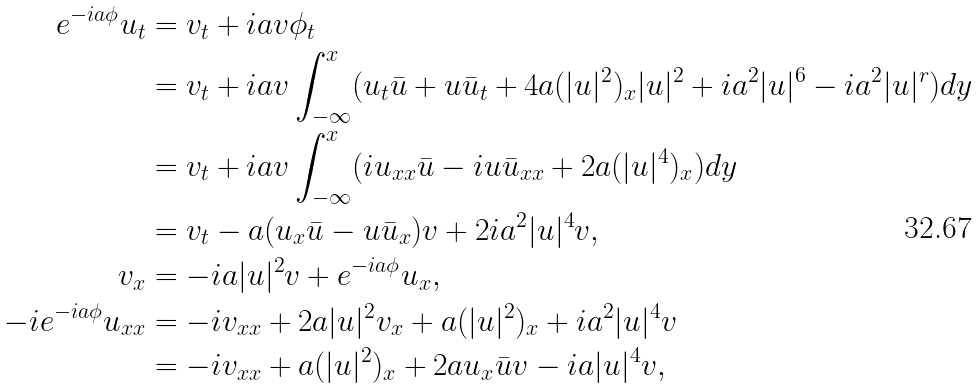Convert formula to latex. <formula><loc_0><loc_0><loc_500><loc_500>e ^ { - i a \phi } u _ { t } & = v _ { t } + i a v \phi _ { t } \\ & = v _ { t } + i a v \int _ { - \infty } ^ { x } ( u _ { t } \bar { u } + u \bar { u } _ { t } + 4 a ( | { u } | ^ { 2 } ) _ { x } | { u } | ^ { 2 } + i a ^ { 2 } | { u } | ^ { 6 } - i a ^ { 2 } | { u } | ^ { r } ) d y \\ & = v _ { t } + i a v \int _ { - \infty } ^ { x } ( i u _ { x x } \bar { u } - i u \bar { u } _ { x x } + 2 a ( | { u } | ^ { 4 } ) _ { x } ) d y \\ & = v _ { t } - a ( u _ { x } \bar { u } - u \bar { u } _ { x } ) v + 2 i a ^ { 2 } | { u } | ^ { 4 } v , \\ v _ { x } & = - i a | { u } | ^ { 2 } v + e ^ { - i a \phi } u _ { x } , \\ - i e ^ { - i a \phi } u _ { x x } & = - i v _ { x x } + 2 a | { u } | ^ { 2 } v _ { x } + a ( | { u } | ^ { 2 } ) _ { x } + i a ^ { 2 } | { u } | ^ { 4 } v \\ & = - i v _ { x x } + a ( | { u } | ^ { 2 } ) _ { x } + 2 a u _ { x } \bar { u } v - i a | { u } | ^ { 4 } v ,</formula> 